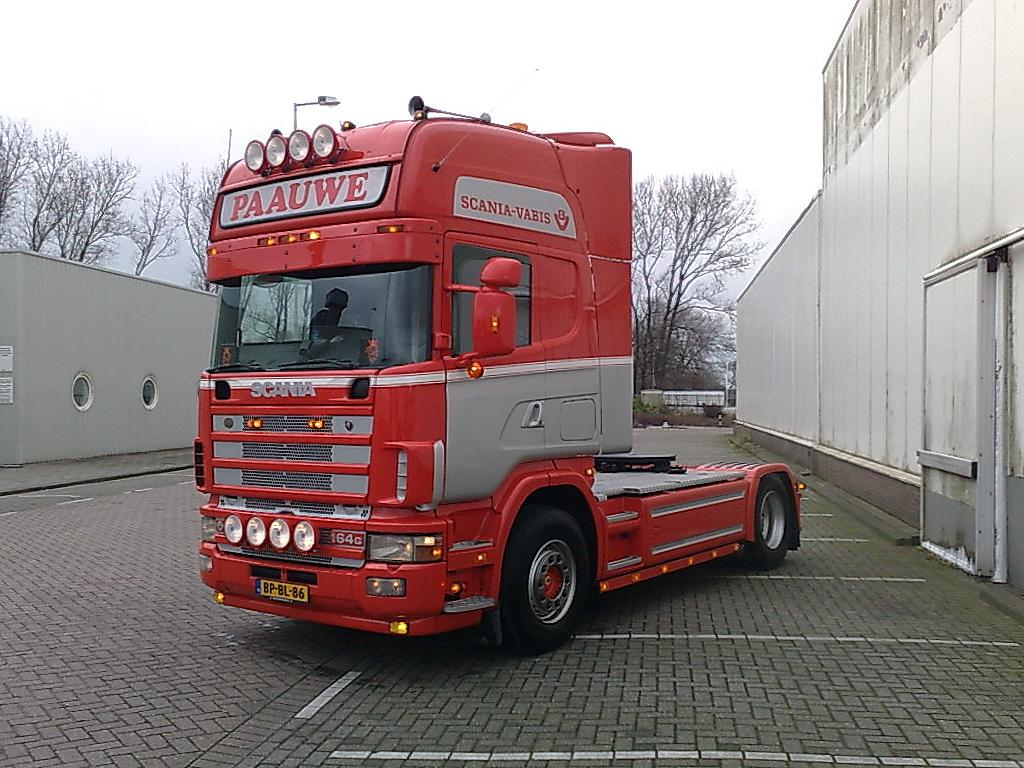What is the main subject in the image? There is a vehicle in the image. What else can be seen in the image besides the vehicle? There is a building, the ground, trees, poles, a light, and the sky visible in the image. Can you describe the setting of the image? The image shows a vehicle near a building, with trees, poles, and a light present. The ground and sky are also visible. What type of plant is being used as a doll in the image? There is no plant or doll present in the image. How does the vehicle in the image take flight? The vehicle in the image does not take flight; it is stationary on the ground. 